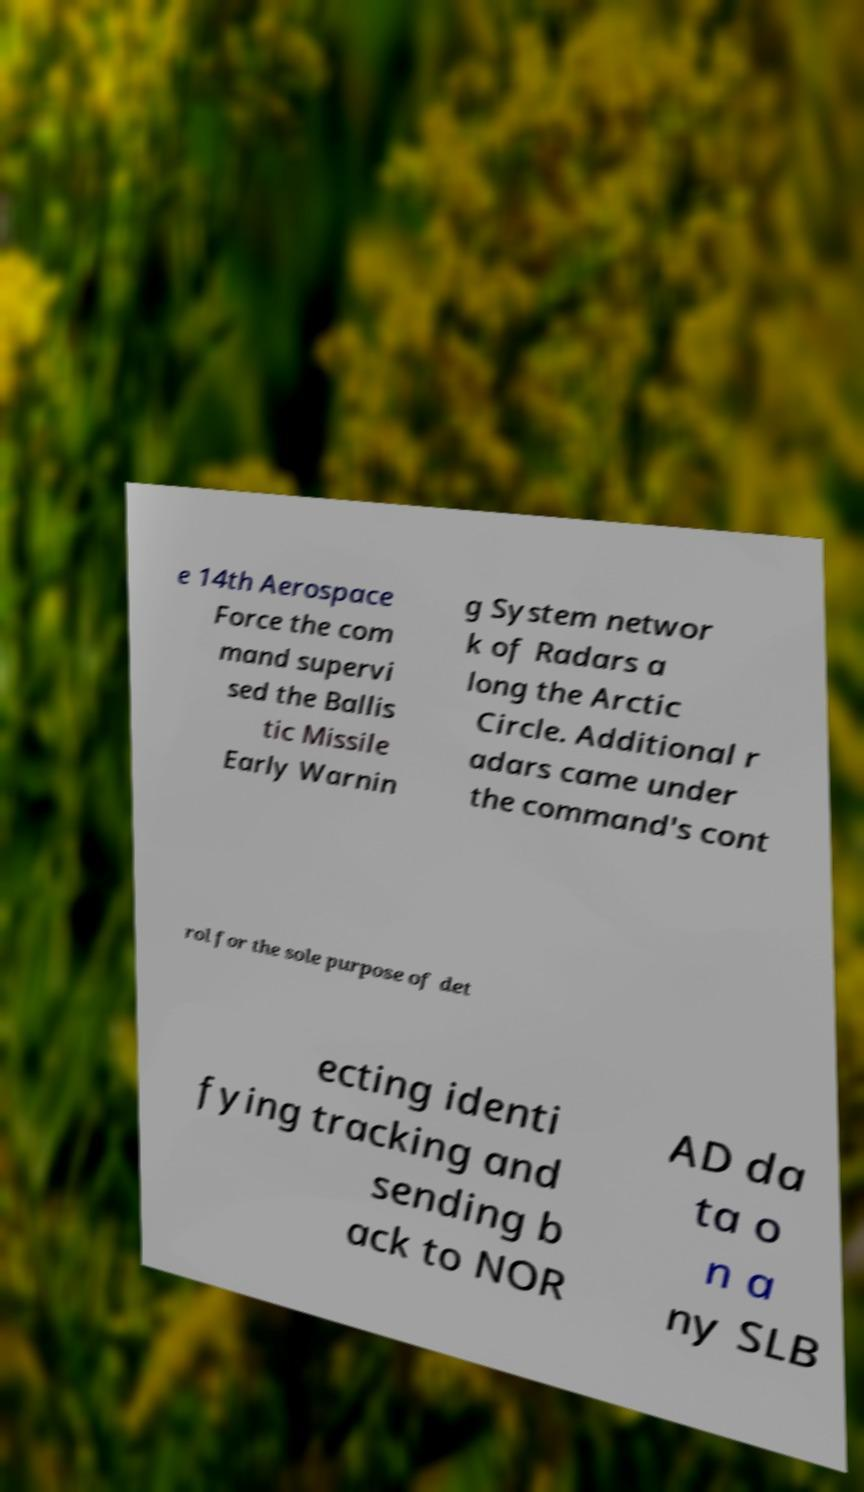Can you read and provide the text displayed in the image?This photo seems to have some interesting text. Can you extract and type it out for me? e 14th Aerospace Force the com mand supervi sed the Ballis tic Missile Early Warnin g System networ k of Radars a long the Arctic Circle. Additional r adars came under the command's cont rol for the sole purpose of det ecting identi fying tracking and sending b ack to NOR AD da ta o n a ny SLB 